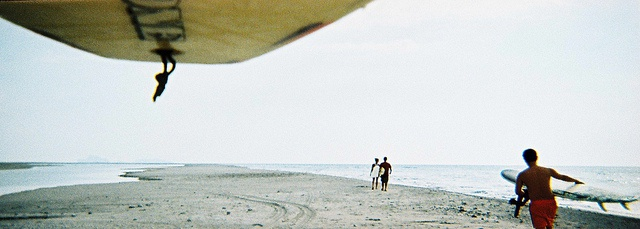Describe the objects in this image and their specific colors. I can see surfboard in black and olive tones, people in black, maroon, brown, and olive tones, surfboard in black, lightgray, darkgray, and teal tones, people in black, white, khaki, and tan tones, and people in black, lightgray, gray, and maroon tones in this image. 